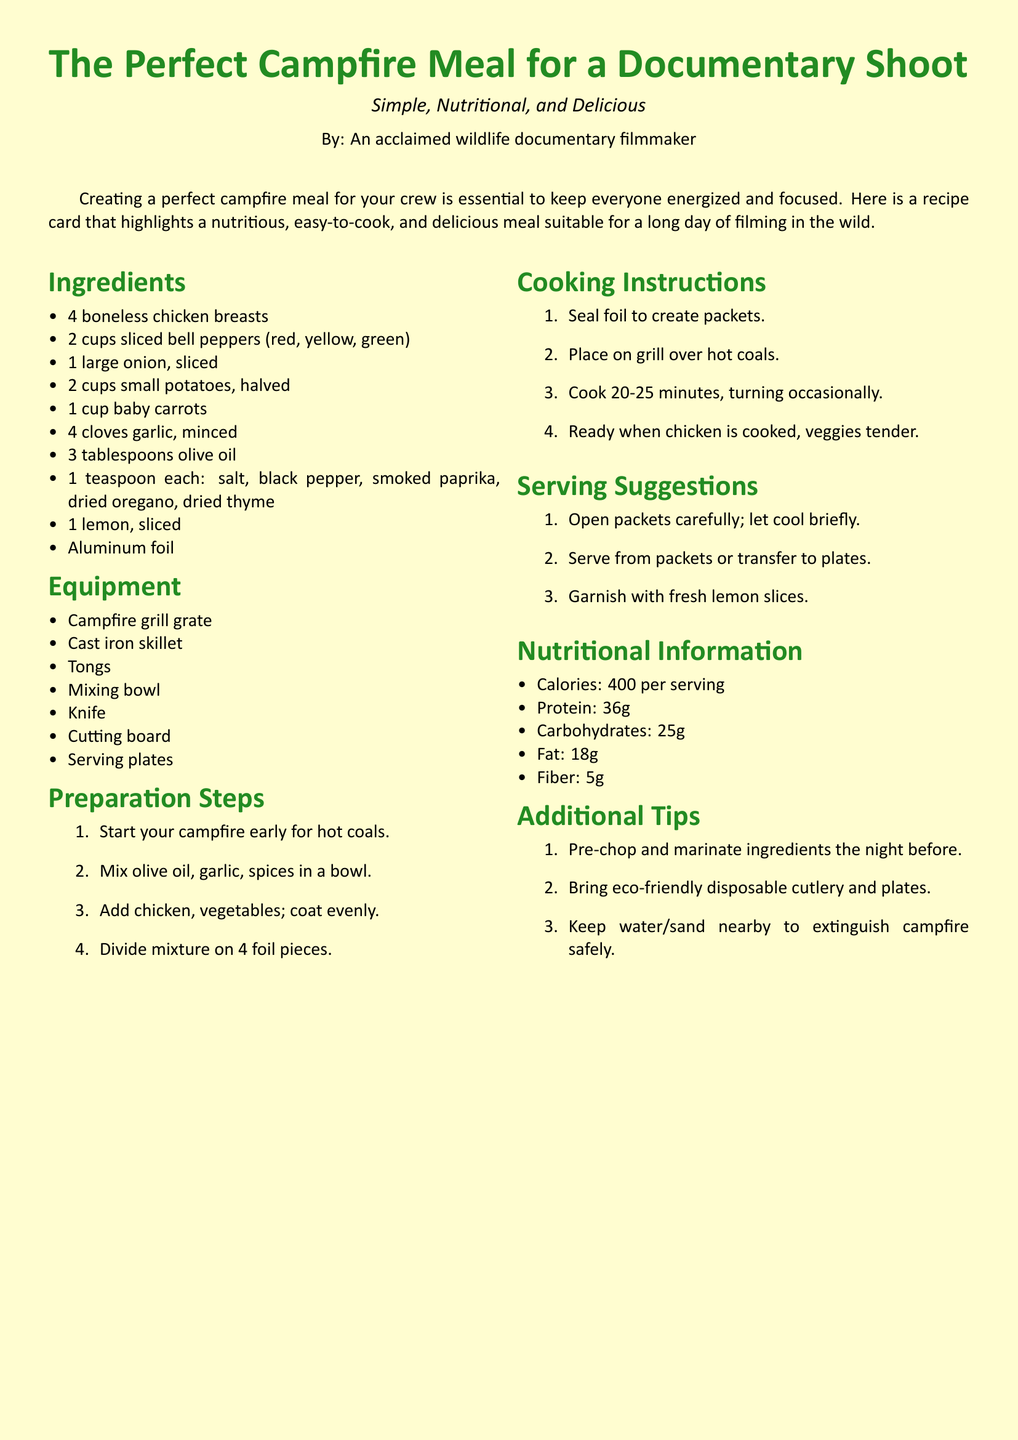What are the main ingredients? The main ingredients can be sourced from the "Ingredients" section in the document, listing chicken, vegetables, and spices.
Answer: 4 boneless chicken breasts, 2 cups sliced bell peppers, 1 large onion, 2 cups small potatoes, 1 cup baby carrots, 4 cloves garlic, 3 tablespoons olive oil, spices, 1 lemon, aluminum foil How long should the chicken be cooked? The cooking duration is specified in the "Cooking Instructions" section, indicating the time needed for the meal to be ready.
Answer: 20-25 minutes What type of meal is suggested for filming? The document describes the meal's characteristics under its introductory text, indicating suitability for filming.
Answer: The Perfect Campfire Meal What is a key tip for meal preparation? Tips for better preparation are provided in the "Additional Tips" section, focusing on pre-preparation advantages.
Answer: Pre-chop and marinate ingredients the night before What is the protein content per serving? Nutritional information, including protein content, is found in the "Nutritional Information" section.
Answer: 36g What equipment is needed for cooking? The equipment listed in the "Equipment" section outlines the necessary tools for the cooking process.
Answer: Campfire grill grate, cast iron skillet, tongs, mixing bowl, knife, cutting board, serving plates How many servings does the recipe provide? The recipe card implies the number of servings based on ingredient quantities used and cooking instructions.
Answer: 4 servings What is the color of the page background? The document specifies the page color in the code, indicating the desired ambiance for the recipe.
Answer: Cream What is a recommended garnish for serving? The "Serving Suggestions" section mentions how to present the meal, including any recommended garnishes.
Answer: Fresh lemon slices 